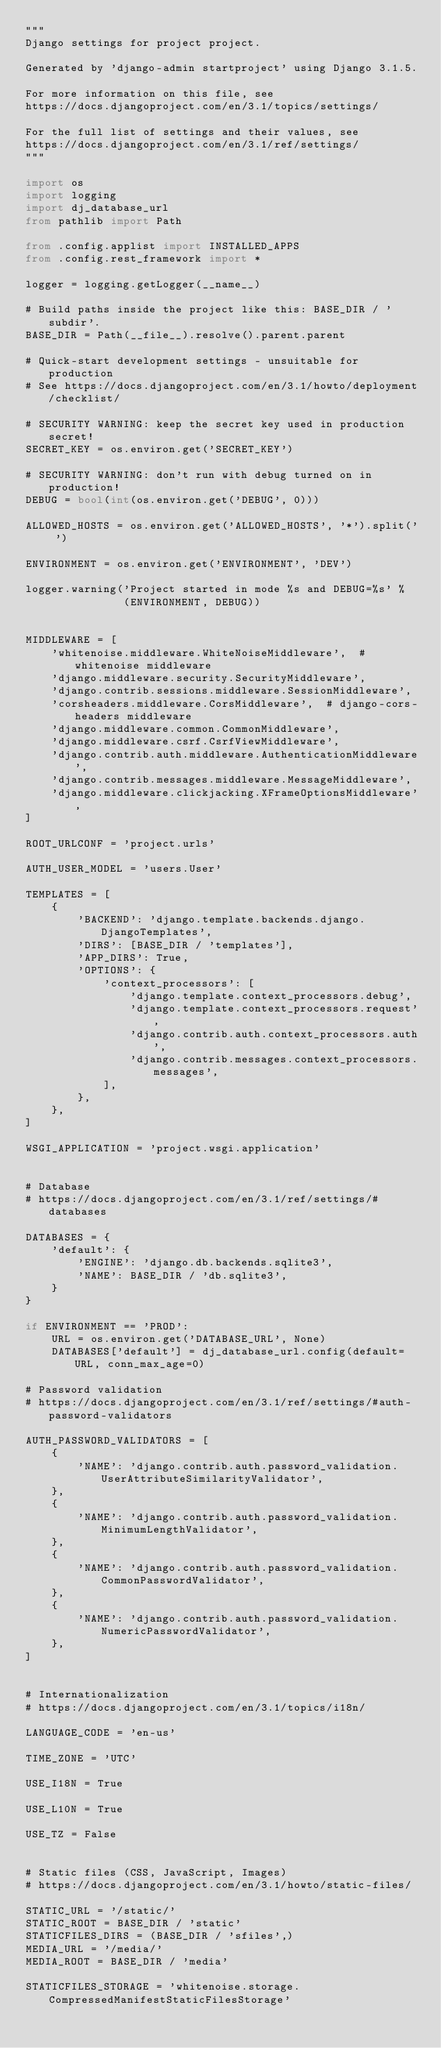<code> <loc_0><loc_0><loc_500><loc_500><_Python_>"""
Django settings for project project.

Generated by 'django-admin startproject' using Django 3.1.5.

For more information on this file, see
https://docs.djangoproject.com/en/3.1/topics/settings/

For the full list of settings and their values, see
https://docs.djangoproject.com/en/3.1/ref/settings/
"""

import os
import logging
import dj_database_url
from pathlib import Path

from .config.applist import INSTALLED_APPS
from .config.rest_framework import *

logger = logging.getLogger(__name__)

# Build paths inside the project like this: BASE_DIR / 'subdir'.
BASE_DIR = Path(__file__).resolve().parent.parent

# Quick-start development settings - unsuitable for production
# See https://docs.djangoproject.com/en/3.1/howto/deployment/checklist/

# SECURITY WARNING: keep the secret key used in production secret!
SECRET_KEY = os.environ.get('SECRET_KEY')

# SECURITY WARNING: don't run with debug turned on in production!
DEBUG = bool(int(os.environ.get('DEBUG', 0)))

ALLOWED_HOSTS = os.environ.get('ALLOWED_HOSTS', '*').split(' ')

ENVIRONMENT = os.environ.get('ENVIRONMENT', 'DEV')

logger.warning('Project started in mode %s and DEBUG=%s' %
               (ENVIRONMENT, DEBUG))


MIDDLEWARE = [
    'whitenoise.middleware.WhiteNoiseMiddleware',  # whitenoise middleware
    'django.middleware.security.SecurityMiddleware',
    'django.contrib.sessions.middleware.SessionMiddleware',
    'corsheaders.middleware.CorsMiddleware',  # django-cors-headers middleware
    'django.middleware.common.CommonMiddleware',
    'django.middleware.csrf.CsrfViewMiddleware',
    'django.contrib.auth.middleware.AuthenticationMiddleware',
    'django.contrib.messages.middleware.MessageMiddleware',
    'django.middleware.clickjacking.XFrameOptionsMiddleware',
]

ROOT_URLCONF = 'project.urls'

AUTH_USER_MODEL = 'users.User'

TEMPLATES = [
    {
        'BACKEND': 'django.template.backends.django.DjangoTemplates',
        'DIRS': [BASE_DIR / 'templates'],
        'APP_DIRS': True,
        'OPTIONS': {
            'context_processors': [
                'django.template.context_processors.debug',
                'django.template.context_processors.request',
                'django.contrib.auth.context_processors.auth',
                'django.contrib.messages.context_processors.messages',
            ],
        },
    },
]

WSGI_APPLICATION = 'project.wsgi.application'


# Database
# https://docs.djangoproject.com/en/3.1/ref/settings/#databases

DATABASES = {
    'default': {
        'ENGINE': 'django.db.backends.sqlite3',
        'NAME': BASE_DIR / 'db.sqlite3',
    }
}

if ENVIRONMENT == 'PROD':
    URL = os.environ.get('DATABASE_URL', None)
    DATABASES['default'] = dj_database_url.config(default=URL, conn_max_age=0)

# Password validation
# https://docs.djangoproject.com/en/3.1/ref/settings/#auth-password-validators

AUTH_PASSWORD_VALIDATORS = [
    {
        'NAME': 'django.contrib.auth.password_validation.UserAttributeSimilarityValidator',
    },
    {
        'NAME': 'django.contrib.auth.password_validation.MinimumLengthValidator',
    },
    {
        'NAME': 'django.contrib.auth.password_validation.CommonPasswordValidator',
    },
    {
        'NAME': 'django.contrib.auth.password_validation.NumericPasswordValidator',
    },
]


# Internationalization
# https://docs.djangoproject.com/en/3.1/topics/i18n/

LANGUAGE_CODE = 'en-us'

TIME_ZONE = 'UTC'

USE_I18N = True

USE_L10N = True

USE_TZ = False


# Static files (CSS, JavaScript, Images)
# https://docs.djangoproject.com/en/3.1/howto/static-files/

STATIC_URL = '/static/'
STATIC_ROOT = BASE_DIR / 'static'
STATICFILES_DIRS = (BASE_DIR / 'sfiles',)
MEDIA_URL = '/media/'
MEDIA_ROOT = BASE_DIR / 'media'

STATICFILES_STORAGE = 'whitenoise.storage.CompressedManifestStaticFilesStorage'
</code> 